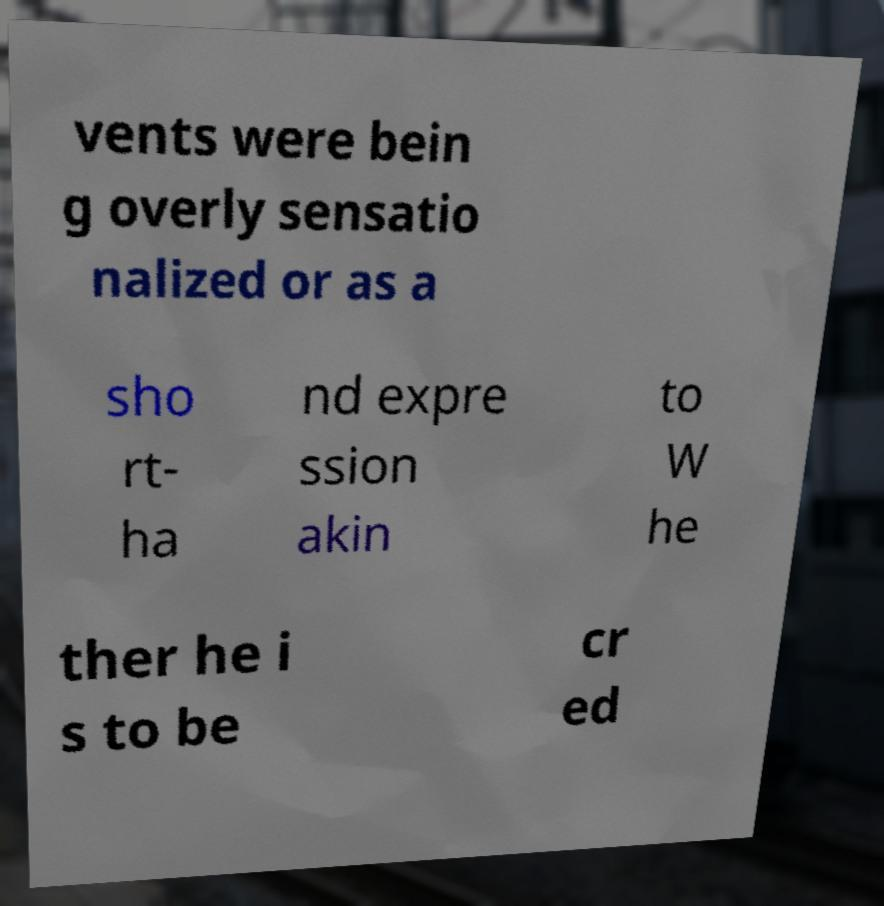I need the written content from this picture converted into text. Can you do that? vents were bein g overly sensatio nalized or as a sho rt- ha nd expre ssion akin to W he ther he i s to be cr ed 